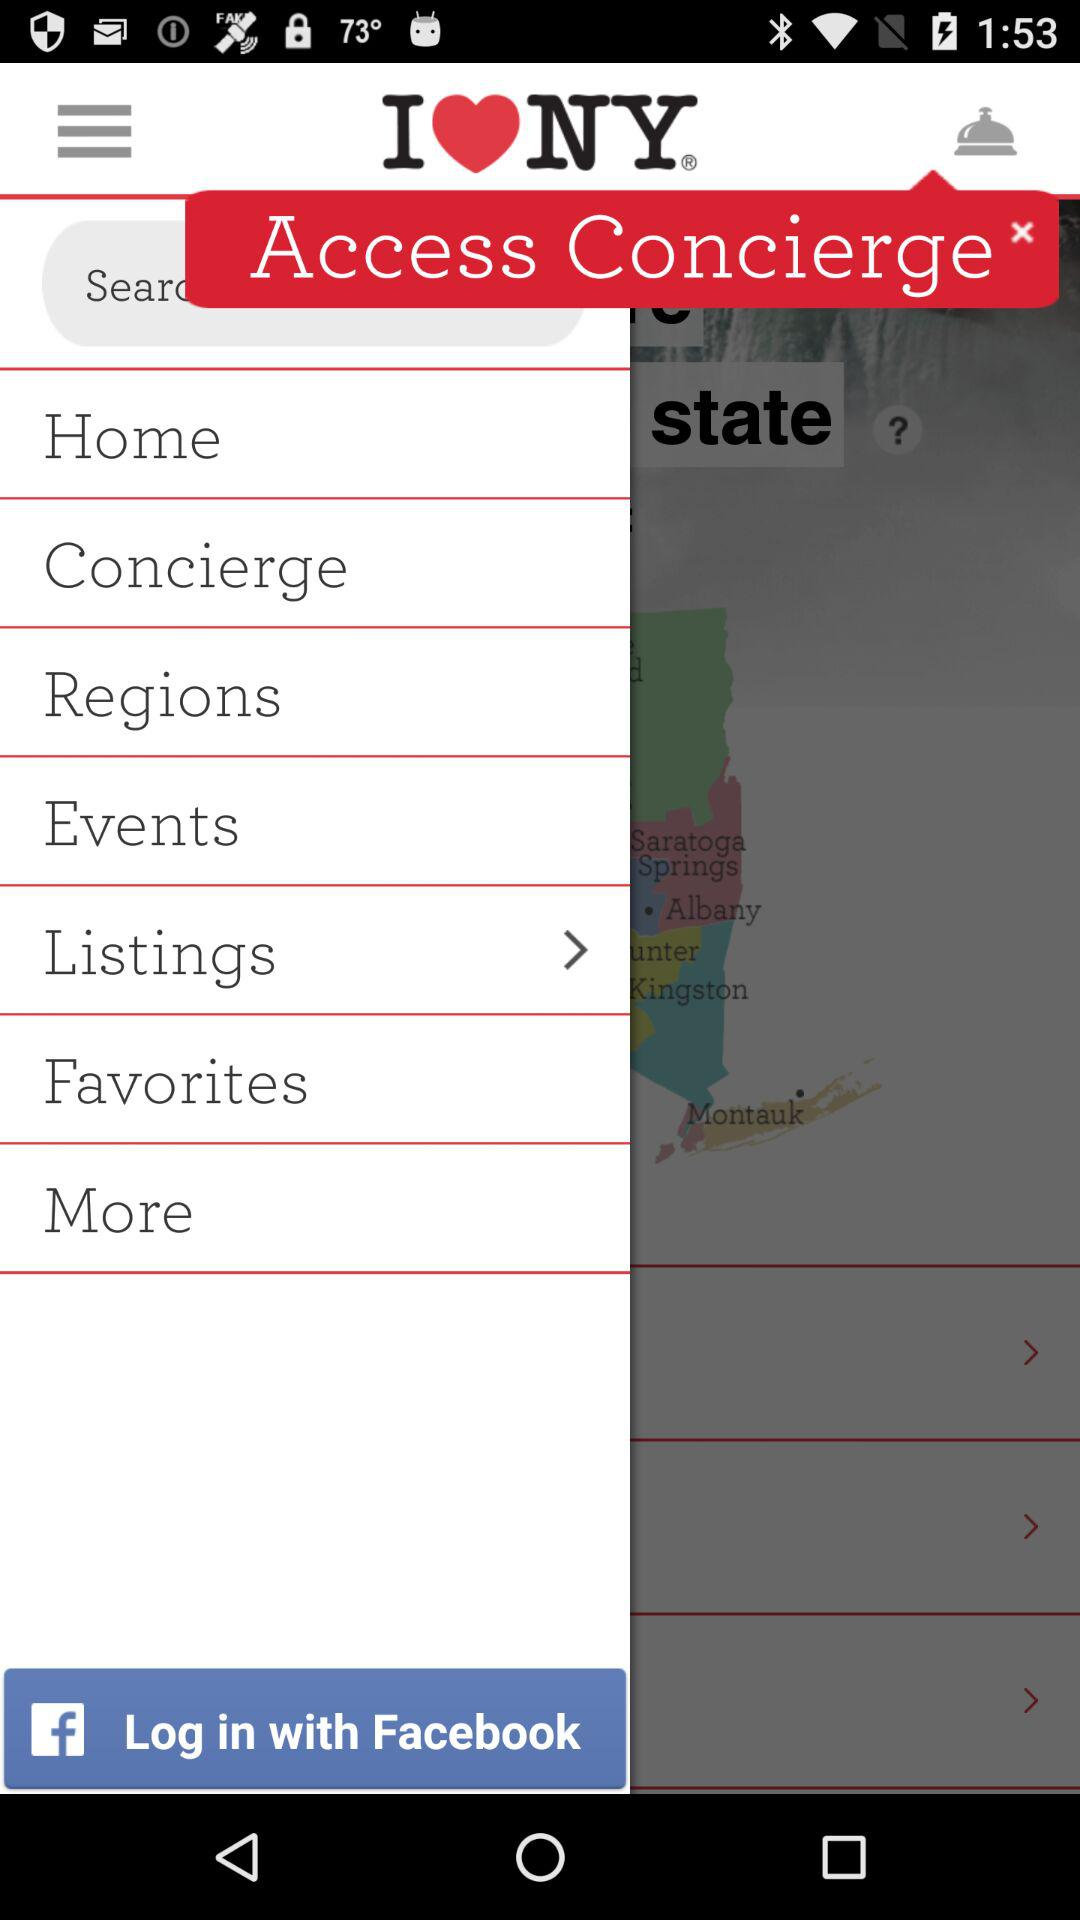What is the application name? The application name is "I Love NY". 